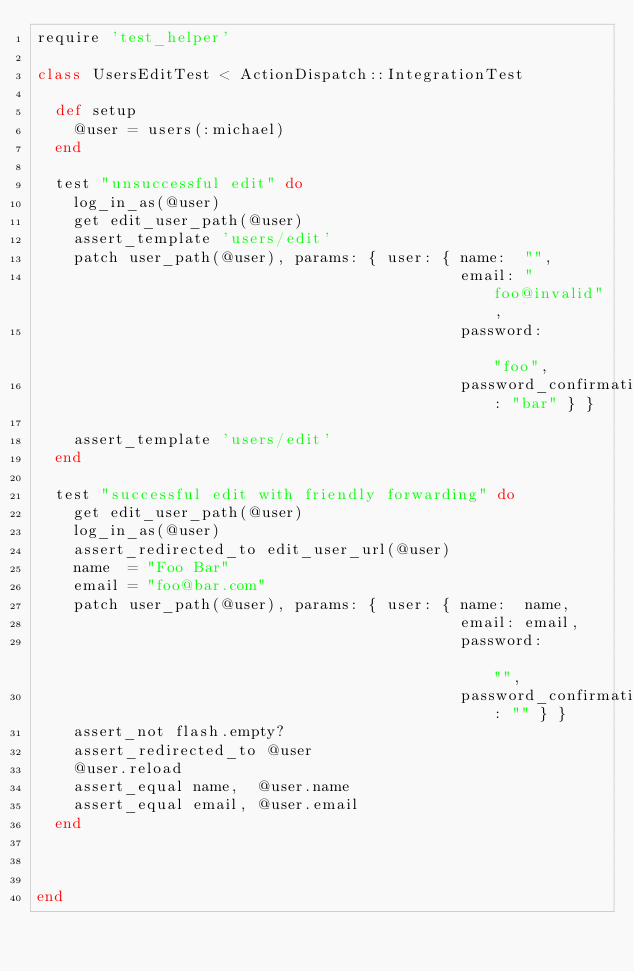<code> <loc_0><loc_0><loc_500><loc_500><_Ruby_>require 'test_helper'

class UsersEditTest < ActionDispatch::IntegrationTest

  def setup
    @user = users(:michael)
  end

  test "unsuccessful edit" do
    log_in_as(@user)
    get edit_user_path(@user)
    assert_template 'users/edit'
    patch user_path(@user), params: { user: { name:  "",
                                              email: "foo@invalid",
                                              password:              "foo",
                                              password_confirmation: "bar" } }

    assert_template 'users/edit'
  end
  
  test "successful edit with friendly forwarding" do
    get edit_user_path(@user)
    log_in_as(@user)
    assert_redirected_to edit_user_url(@user)
    name  = "Foo Bar"
    email = "foo@bar.com"
    patch user_path(@user), params: { user: { name:  name,
                                              email: email,
                                              password:              "",
                                              password_confirmation: "" } }
    assert_not flash.empty?
    assert_redirected_to @user
    @user.reload
    assert_equal name,  @user.name
    assert_equal email, @user.email
  end
  
  
  
end</code> 